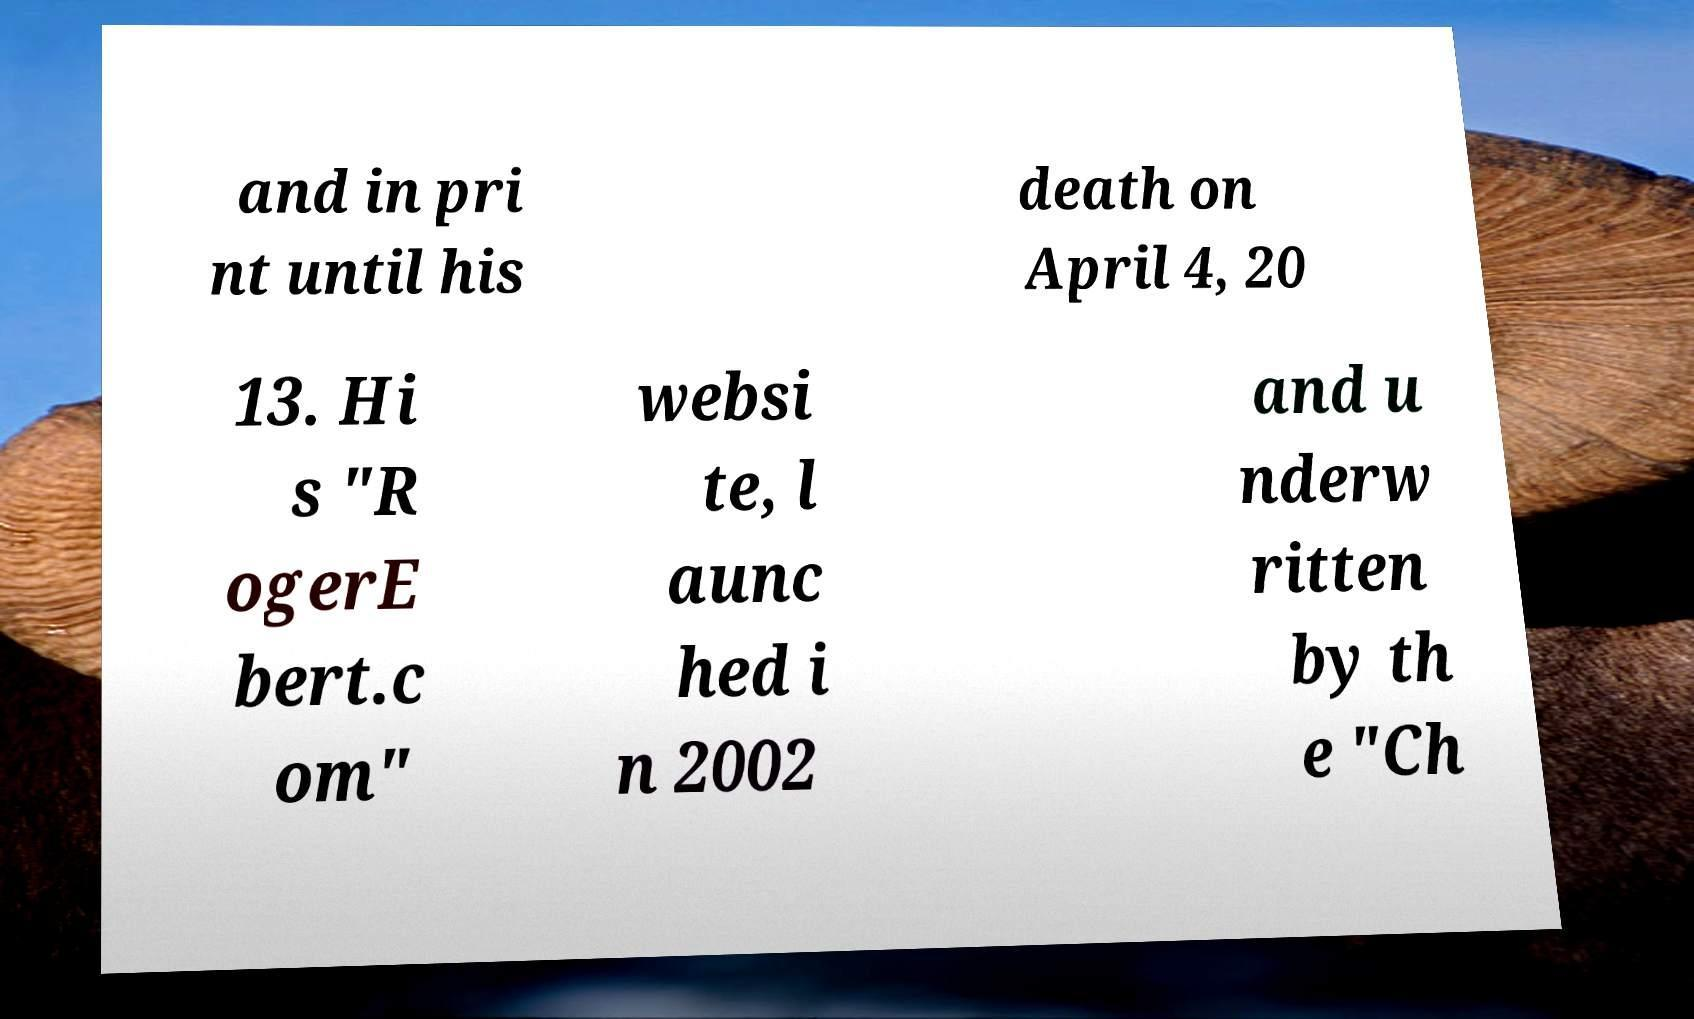Please read and relay the text visible in this image. What does it say? and in pri nt until his death on April 4, 20 13. Hi s "R ogerE bert.c om" websi te, l aunc hed i n 2002 and u nderw ritten by th e "Ch 